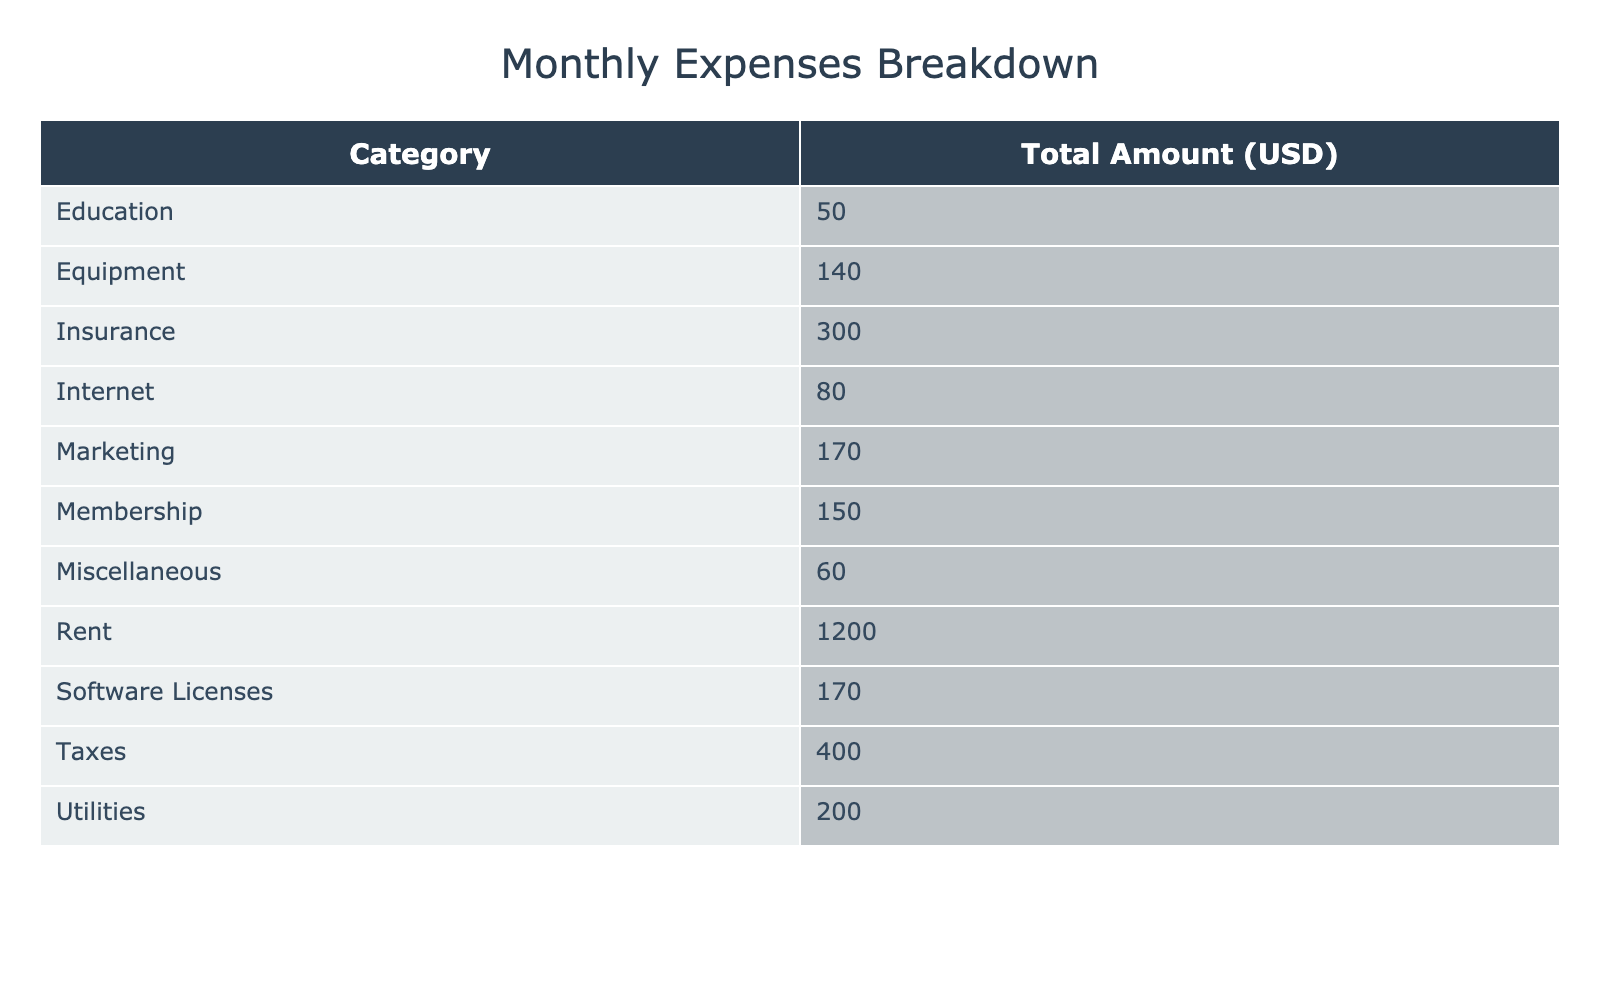What is the total amount spent on Software Licenses? To find the total for Software Licenses, we look for the amounts listed under that category: $120 (IDE Subscription) + $50 (Design Tool License) = $170.
Answer: 170 What is the largest single expense category? We can see the total amounts for each category in the table. The categories with the highest total are Rent at $1200, followed by Taxes at $400. Rent is the largest category.
Answer: Rent What is the total amount spent on Marketing? The Marketing category has two entries: $20 (Website Hosting) and $150 (Online Ads). Adding these together gives $20 + $150 = $170.
Answer: 170 Is the amount spent on Utilities greater than that spent on Equipment? The total Utilities amount is $200 (Electricity and Water) while Equipment amounts to $100 (Laptop) + $40 (Keyboard and Mouse) = $140. $200 is greater than $140.
Answer: Yes What is the average monthly expense for the Education category? There's only one entry in Education, which is the Online Courses expense of $50. The average is then equal to that amount, as there are no other values to consider.
Answer: 50 If you combine the amounts for Rent and Insurance, what is the total? Rent is $1200 and Insurance is $300. Adding these gives us $1200 + $300 = $1500.
Answer: 1500 What percentage of total expenses does the amount spent on Internet represent? First, we sum all expenses: $1200 (Rent) + $200 (Utilities) + $80 (Internet) + $170 (Software Licenses) + $150 (Membership) + $300 (Insurance) + $20 (Marketing) + $150 (Marketing) + $100 (Equipment) + $40 (Equipment) + $50 (Education) + $400 (Taxes) + $60 (Miscellaneous) = $2800. The Internet amount is $80, and the percentage is ($80 / $2800) * 100 = 2.857%.
Answer: 2.86% Which category has the least amount spent? In the table, Miscellaneous has an amount of $60, which is the lowest when comparing all categories total amounts.
Answer: Miscellaneous How much more was spent on Taxes than on Marketing? Taxes amount to $400 while combined Marketing is $170 ($20 + $150). The difference is $400 - $170 = $230, meaning $230 more was spent on Taxes.
Answer: 230 What is the total amount spent across all categories? To find the total, we need to sum all the amounts listed in the table: $1200 + $200 + $80 + $170 + $50 + $150 + $300 + $20 + $150 + $100 + $40 + $50 + $400 + $60 = $2800.
Answer: 2800 